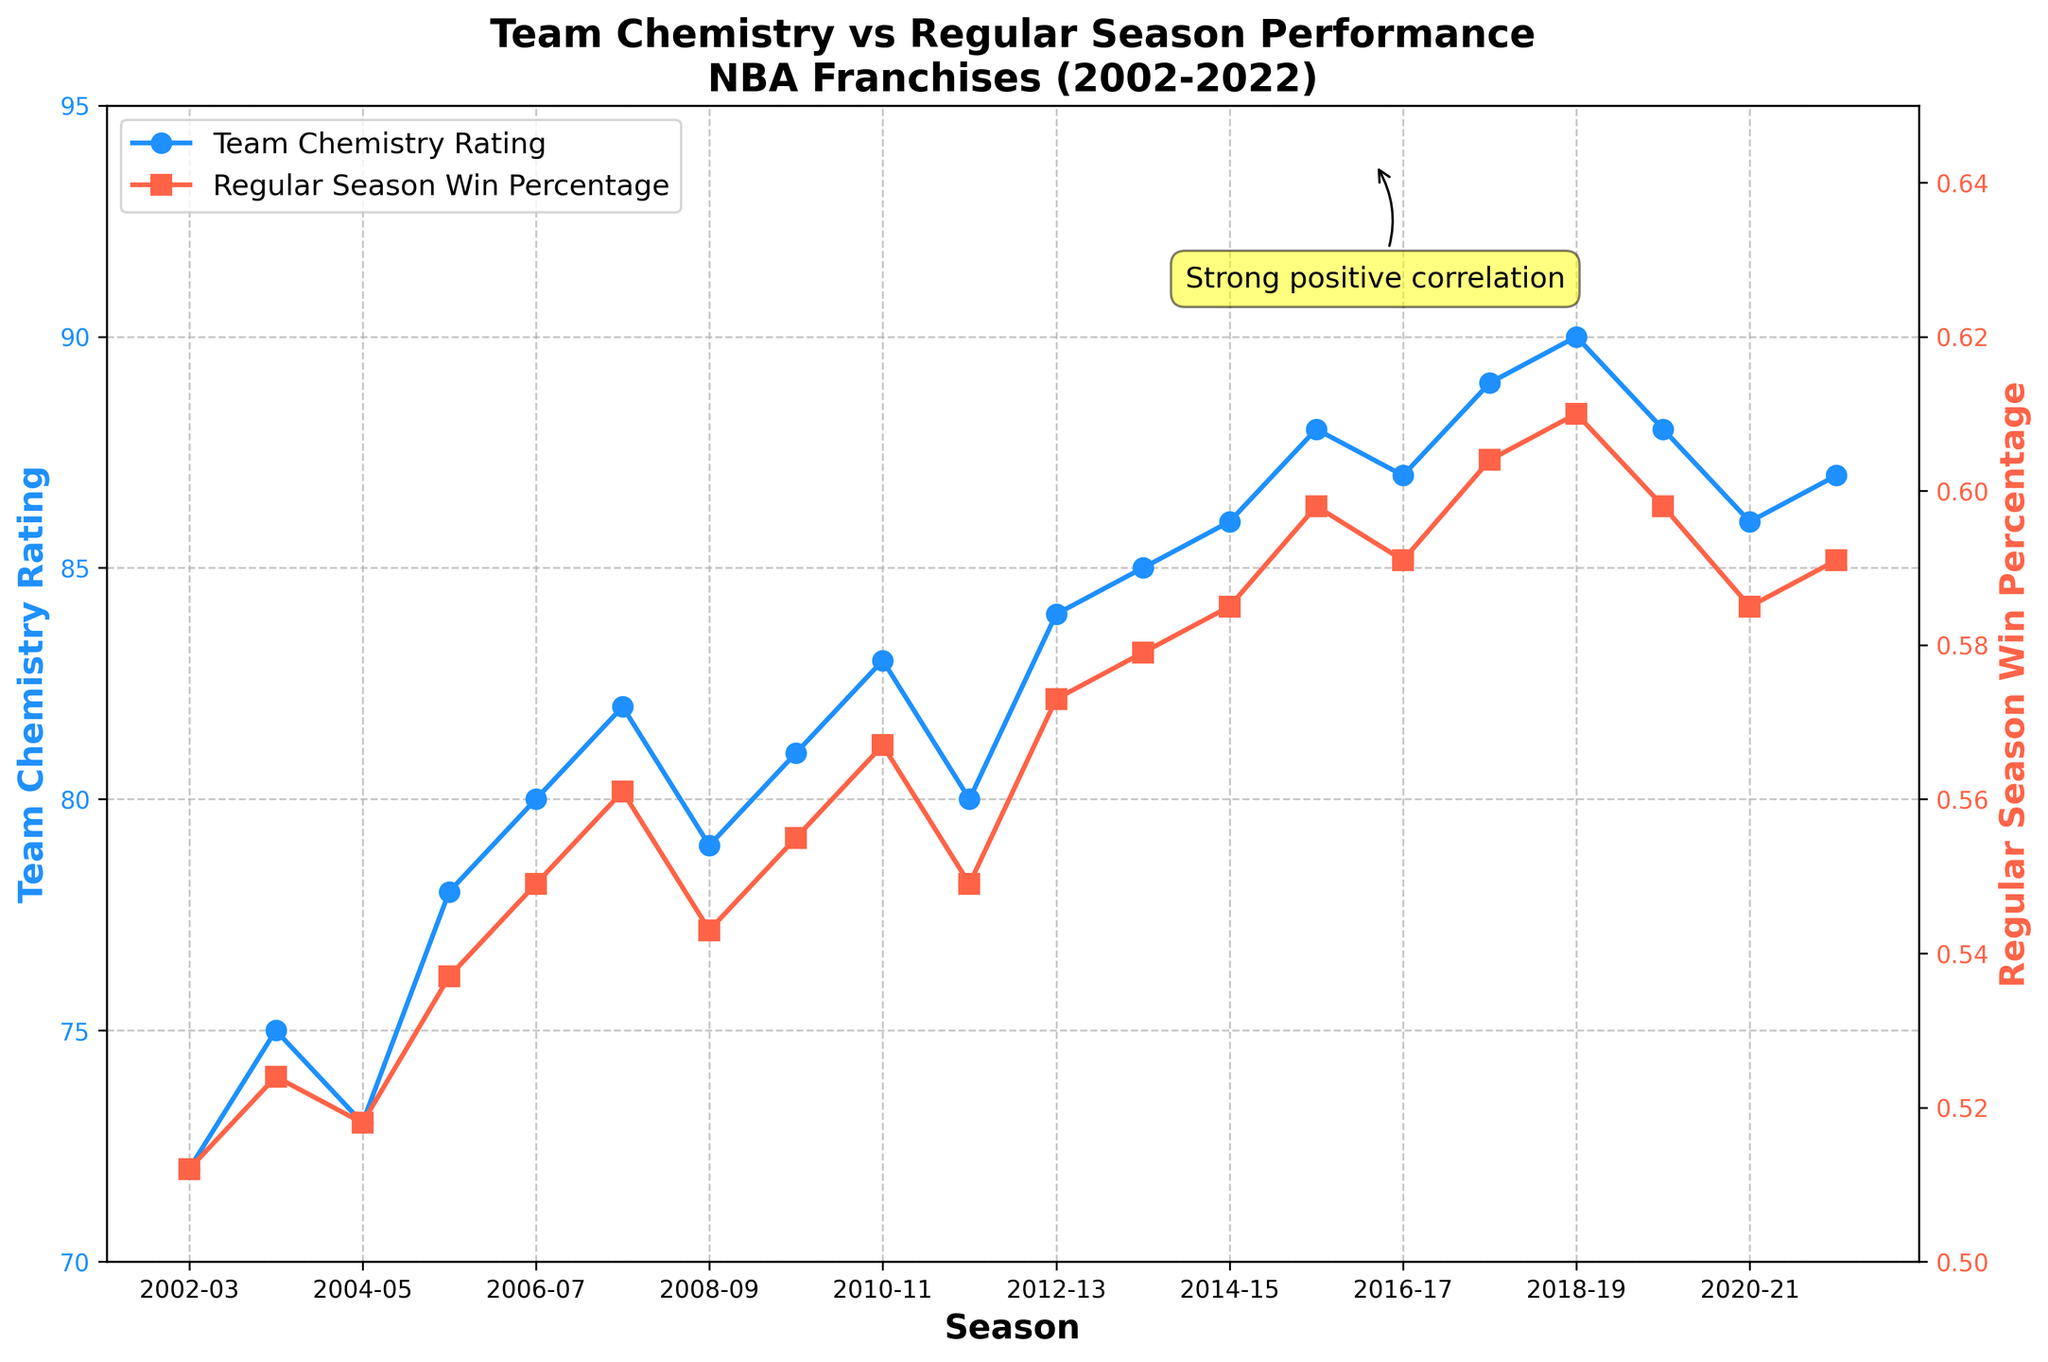Which season had the highest Team Chemistry Rating? To find the highest Team Chemistry Rating, look for the peak point on the blue line representing the Team Chemistry Rating. The highest point on this line corresponds to the season 2018-19 with a rating of 90.
Answer: 2018-19 What's the average Win Percentage for the seasons where the Team Chemistry Rating is above 85? First, identify the seasons where the Team Chemistry Rating is above 85 (2014-15, 2015-16, 2016-17, 2017-18, 2018-19, 2019-20, 2021-22). Then, sum their Regular Season Win Percentages and divide by the number of seasons: (0.585 + 0.598 + 0.591 + 0.604 + 0.610 + 0.598 + 0.591) / 7 = 0.596
Answer: 0.596 How does the Win Percentage change as the Team Chemistry Rating increases from 80 to 90? Observe the trend in the red line (Win Percentage) as the blue line (Team Chemistry Rating) increases from 80 to 90. The Regular Season Win Percentage increases from around 0.549 to 0.610 as the Team Chemistry Rating moves from 80 to 90, indicating a positive correlation.
Answer: Increases Which visual attributes are used to differentiate between the Team Chemistry Rating and Win Percentage in the plot? The plot uses different colors and markers to differentiate between the two metrics. The Team Chemistry Rating is represented by a blue line with circular markers, and the Win Percentage is shown by a red line with square markers.
Answer: Colors and markers During which seasons did the Team Chemistry Rating and Win Percentage both show a noticeable increase? Identify the periods where both lines show an upward trend. From 2006-07 to 2010-11, both the Team Chemistry Rating and the Win Percentage exhibit noticeable increases together. Another period is from 2014-15 to 2018-19.
Answer: 2006-07 to 2010-11 and 2014-15 to 2018-19 What is the difference in Regular Season Win Percentage between the 2002-03 and 2018-19 seasons? Subtract the Win Percentage of the 2002-03 season from that of the 2018-19 season. The Win Percentage for 2002-03 is 0.512 and for 2018-19 is 0.610. So, the difference is 0.610 - 0.512 = 0.098
Answer: 0.098 